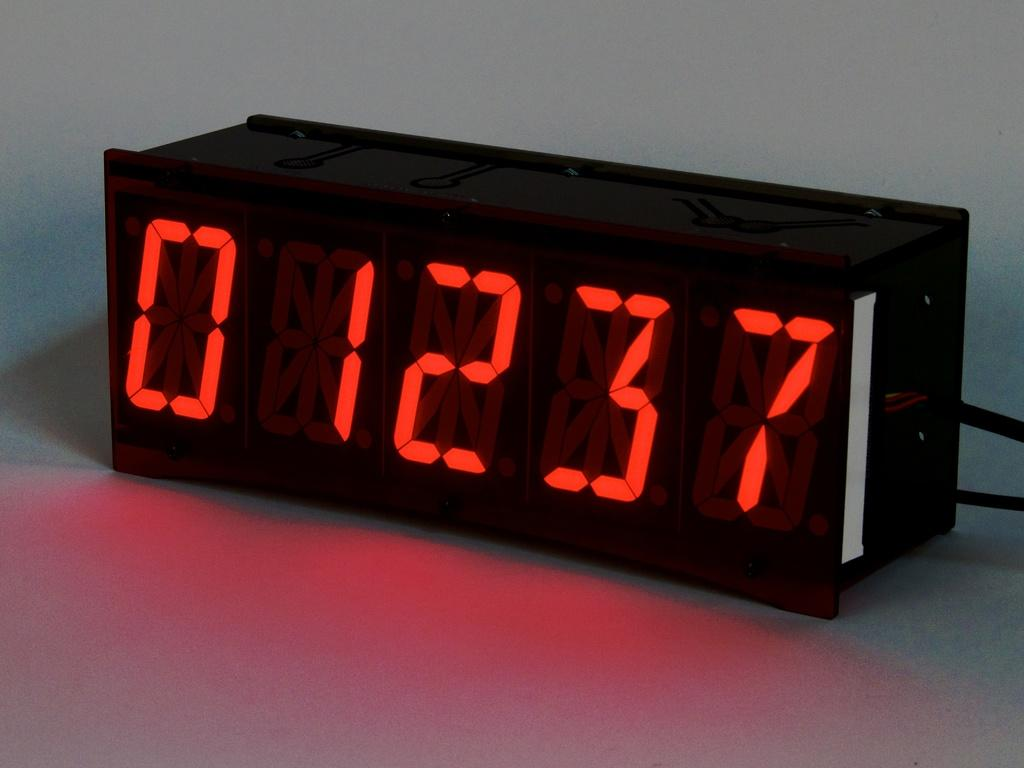<image>
Share a concise interpretation of the image provided. A countdown timer says 01237 in red numbers. 